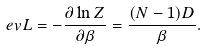<formula> <loc_0><loc_0><loc_500><loc_500>\ e v { L } = - \frac { \partial \ln Z } { \partial \beta } = \frac { ( N - 1 ) D } { \beta } .</formula> 